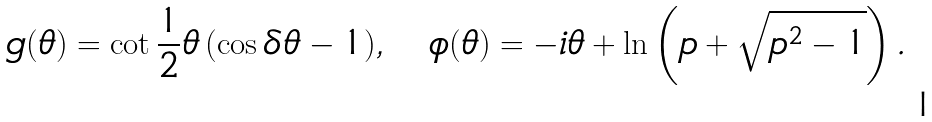<formula> <loc_0><loc_0><loc_500><loc_500>g ( \theta ) = \cot \frac { 1 } { 2 } \theta \, ( \cos \delta \theta - 1 ) , \quad \phi ( \theta ) = - i \theta + \ln \left ( p + \sqrt { p ^ { 2 } - 1 } \right ) .</formula> 